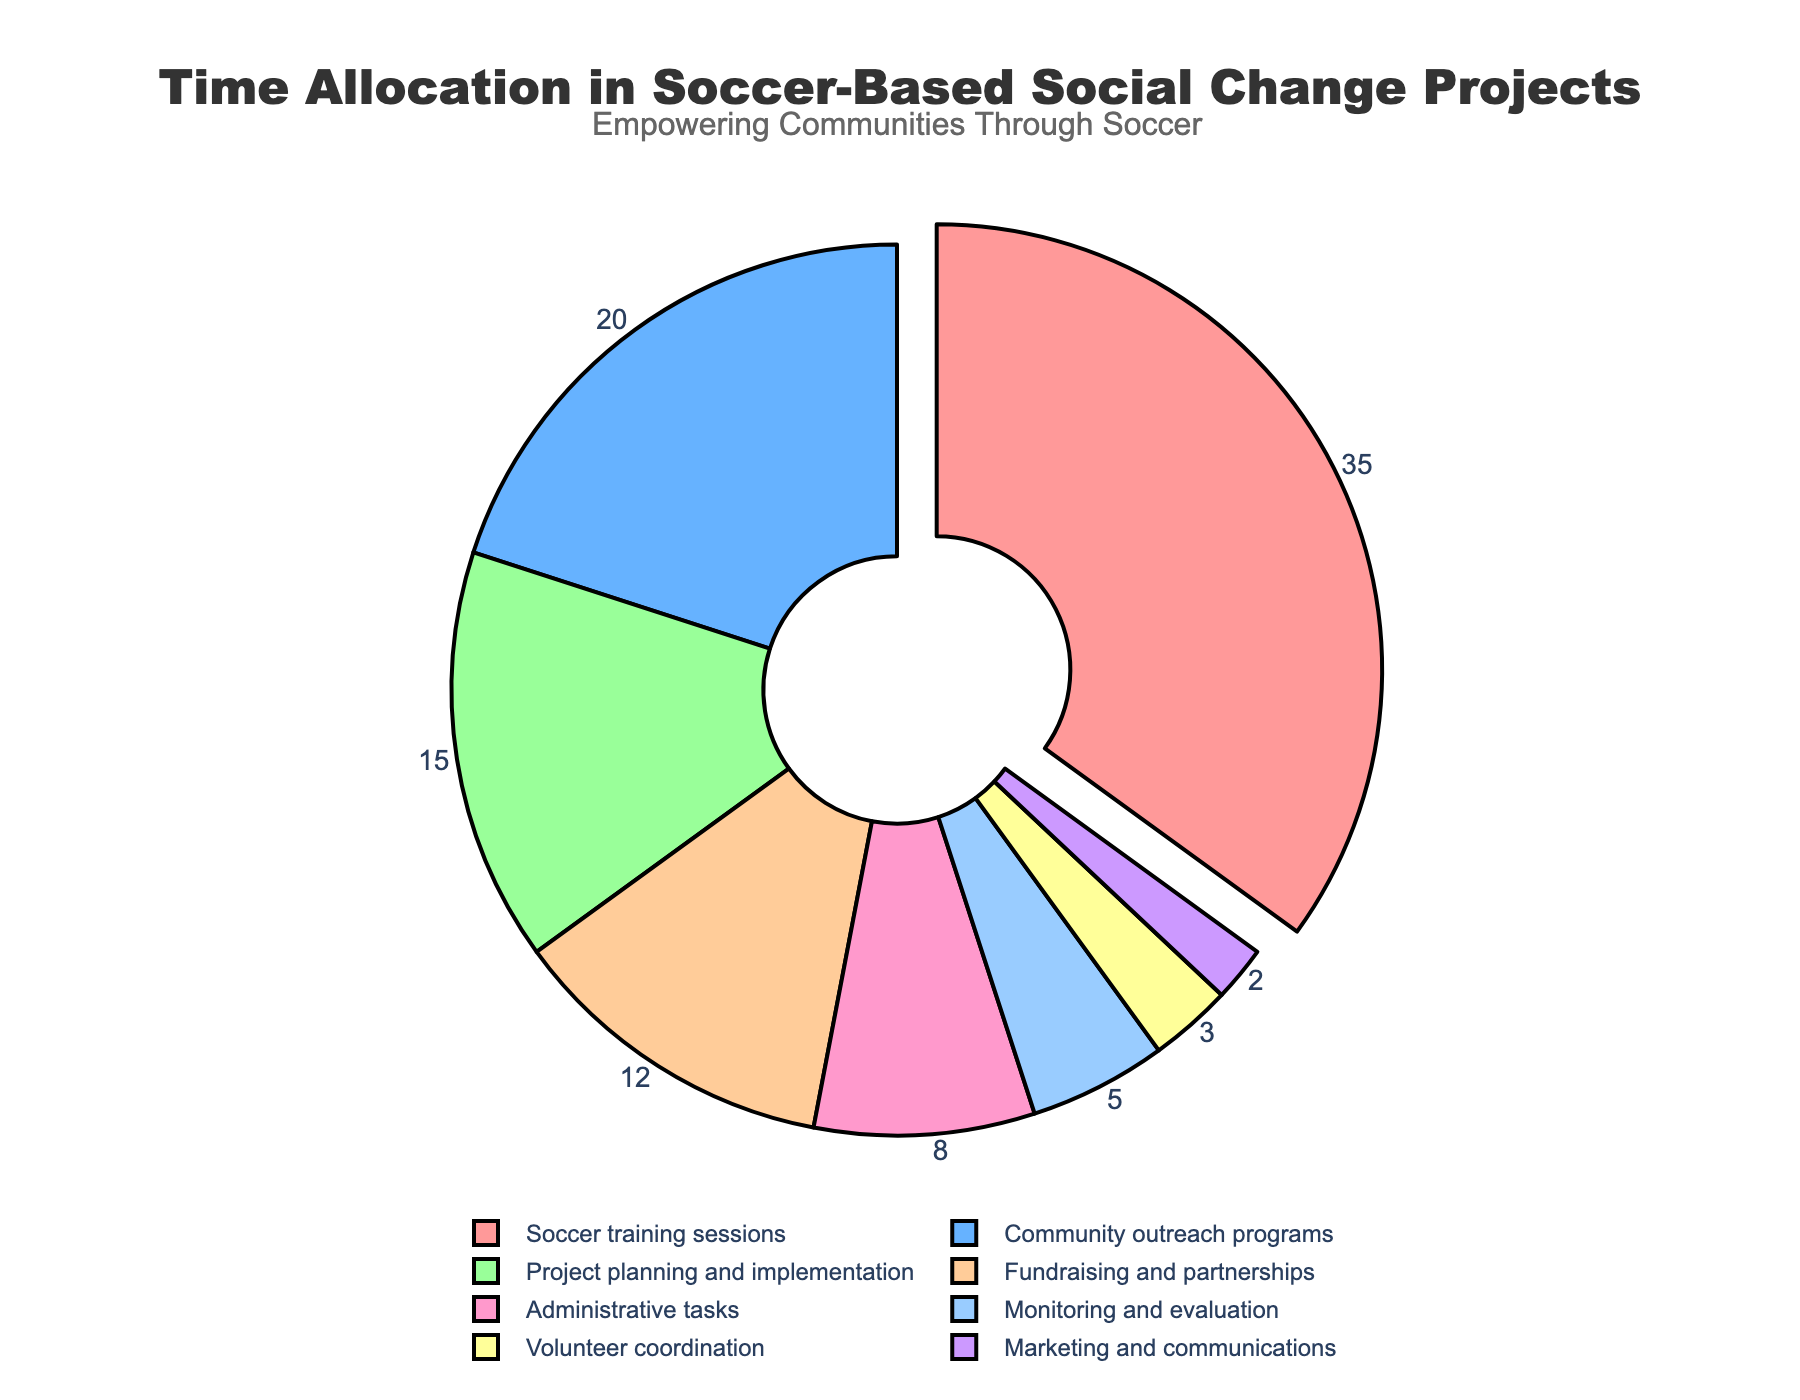What's the largest percentage activity and how much is it? The largest percentage activity is highlighted visually in the pie chart. Identify the largest slice and read its label.
Answer: Soccer training sessions, 35% What's the combined percentage of community outreach programs and project planning and implementation? Add the percentages of both activities together. Community outreach programs (20%) + Project planning and implementation (15%).
Answer: 35% Which two activities have the smallest percentage allocation and what are their percentages? Look for the two smallest slices in the pie chart and read their labels and percentages.
Answer: Marketing and communications (2%) and Volunteer coordination (3%) How does the percentage time spent on administrative tasks compare to fundraising and partnerships? Compare the sizes of the slices for administrative tasks and fundraising and partnerships. Administrative tasks are 8%, fundraising and partnerships are 12%.
Answer: Administrative tasks are less than fundraising and partnerships What's the average percentage of time spent on monitoring and evaluation, volunteer coordination, and marketing and communications? Add the percentages of these three activities and divide by 3. (5% + 3% + 2%) / 3 = 10% / 3.
Answer: Approximately 3.33% If the total percentage of time spent on soccer training sessions and community outreach programs were reduced by 10%, what would their new combined percentage be? Calculate the combined percentage, reduce by 10%, then find the new value. Current combined (35% + 20%) = 55%; 55% - 10% = 45%.
Answer: 45% Which activity has a percentage allocation less than 10% but more than 5%? Identify the slice that falls between 5% and 10%.
Answer: Administrative tasks (8%) What is the ratio between the time spent on project planning and implementation and volunteer coordination? Divide the percentage of project planning and implementation by the percentage of volunteer coordination. 15% / 3% = 5.
Answer: 5:1 How much more time is spent on community outreach programs compared to monitoring and evaluation? Subtract the percentage of monitoring and evaluation from community outreach programs. 20% - 5% = 15%.
Answer: 15% 